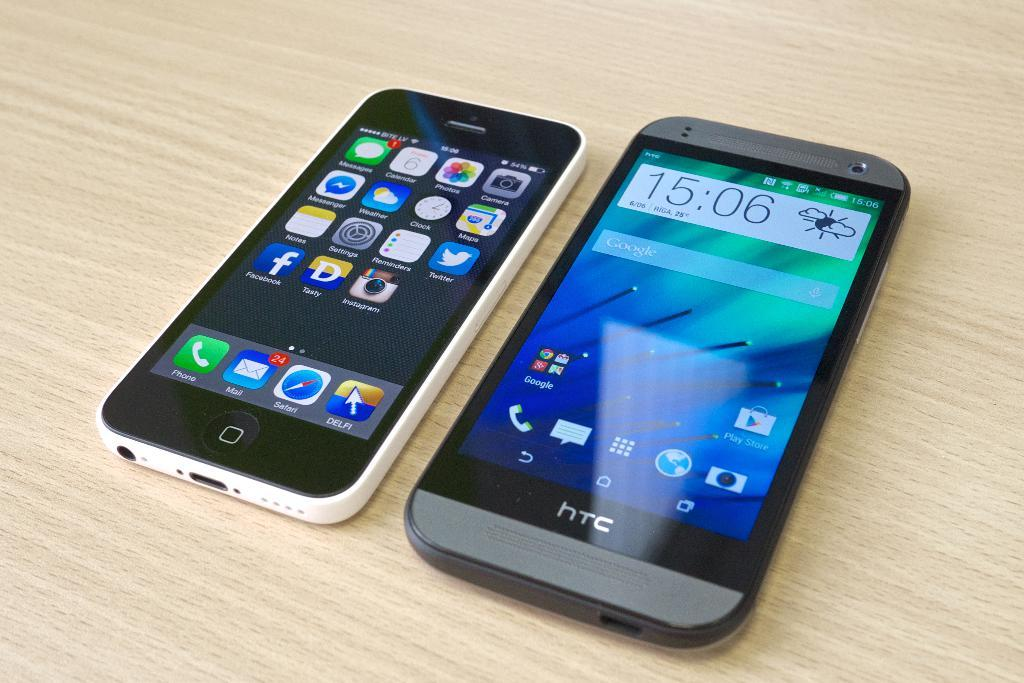Provide a one-sentence caption for the provided image. Two smartphones lie next to each other on a table at 15:06. 